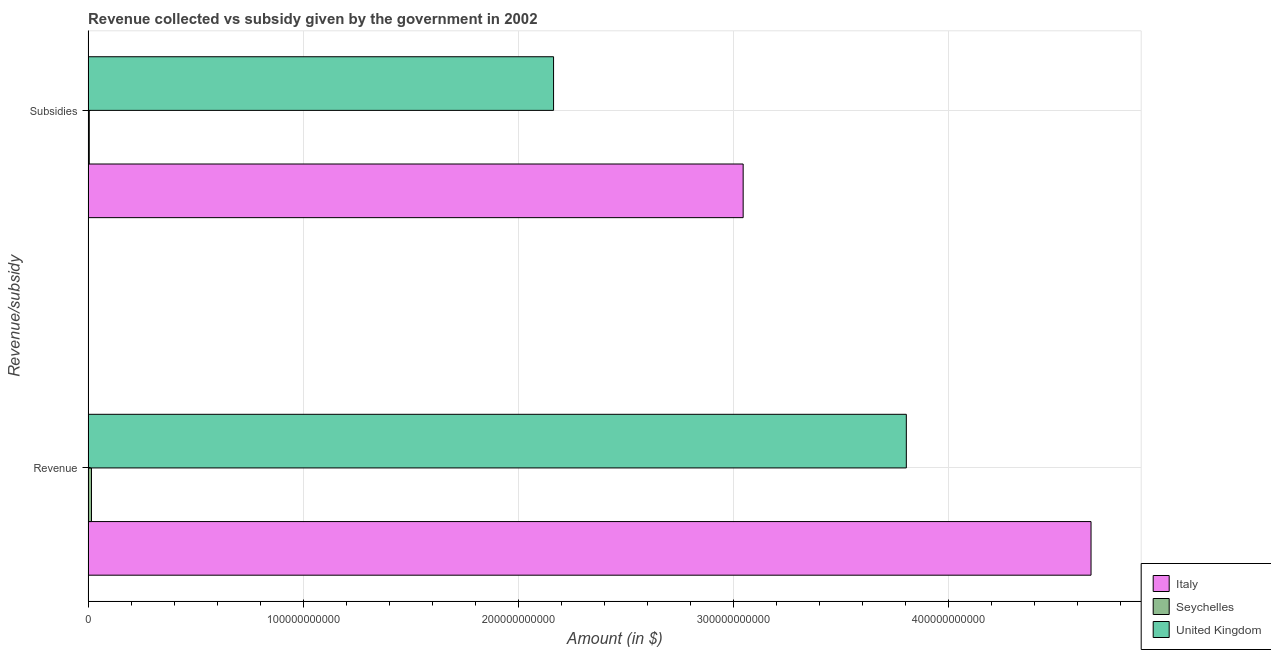How many different coloured bars are there?
Ensure brevity in your answer.  3. How many groups of bars are there?
Provide a short and direct response. 2. What is the label of the 1st group of bars from the top?
Your answer should be very brief. Subsidies. What is the amount of subsidies given in Italy?
Ensure brevity in your answer.  3.05e+11. Across all countries, what is the maximum amount of subsidies given?
Provide a succinct answer. 3.05e+11. Across all countries, what is the minimum amount of subsidies given?
Keep it short and to the point. 5.48e+08. In which country was the amount of revenue collected maximum?
Keep it short and to the point. Italy. In which country was the amount of subsidies given minimum?
Offer a terse response. Seychelles. What is the total amount of revenue collected in the graph?
Provide a short and direct response. 8.49e+11. What is the difference between the amount of revenue collected in Seychelles and that in Italy?
Provide a succinct answer. -4.65e+11. What is the difference between the amount of subsidies given in United Kingdom and the amount of revenue collected in Seychelles?
Give a very brief answer. 2.15e+11. What is the average amount of revenue collected per country?
Make the answer very short. 2.83e+11. What is the difference between the amount of revenue collected and amount of subsidies given in Seychelles?
Make the answer very short. 1.03e+09. What is the ratio of the amount of subsidies given in Seychelles to that in United Kingdom?
Offer a terse response. 0. What does the 2nd bar from the bottom in Subsidies represents?
Your answer should be very brief. Seychelles. How many bars are there?
Offer a terse response. 6. Are all the bars in the graph horizontal?
Provide a succinct answer. Yes. How many countries are there in the graph?
Make the answer very short. 3. What is the difference between two consecutive major ticks on the X-axis?
Your answer should be very brief. 1.00e+11. Are the values on the major ticks of X-axis written in scientific E-notation?
Provide a short and direct response. No. Does the graph contain any zero values?
Your answer should be very brief. No. Where does the legend appear in the graph?
Give a very brief answer. Bottom right. How are the legend labels stacked?
Provide a short and direct response. Vertical. What is the title of the graph?
Give a very brief answer. Revenue collected vs subsidy given by the government in 2002. Does "Moldova" appear as one of the legend labels in the graph?
Your response must be concise. No. What is the label or title of the X-axis?
Offer a terse response. Amount (in $). What is the label or title of the Y-axis?
Keep it short and to the point. Revenue/subsidy. What is the Amount (in $) of Italy in Revenue?
Your answer should be compact. 4.66e+11. What is the Amount (in $) of Seychelles in Revenue?
Your answer should be compact. 1.58e+09. What is the Amount (in $) in United Kingdom in Revenue?
Your answer should be compact. 3.81e+11. What is the Amount (in $) in Italy in Subsidies?
Make the answer very short. 3.05e+11. What is the Amount (in $) of Seychelles in Subsidies?
Give a very brief answer. 5.48e+08. What is the Amount (in $) of United Kingdom in Subsidies?
Offer a very short reply. 2.16e+11. Across all Revenue/subsidy, what is the maximum Amount (in $) of Italy?
Ensure brevity in your answer.  4.66e+11. Across all Revenue/subsidy, what is the maximum Amount (in $) in Seychelles?
Your answer should be compact. 1.58e+09. Across all Revenue/subsidy, what is the maximum Amount (in $) in United Kingdom?
Ensure brevity in your answer.  3.81e+11. Across all Revenue/subsidy, what is the minimum Amount (in $) in Italy?
Provide a short and direct response. 3.05e+11. Across all Revenue/subsidy, what is the minimum Amount (in $) of Seychelles?
Ensure brevity in your answer.  5.48e+08. Across all Revenue/subsidy, what is the minimum Amount (in $) in United Kingdom?
Keep it short and to the point. 2.16e+11. What is the total Amount (in $) of Italy in the graph?
Your answer should be compact. 7.71e+11. What is the total Amount (in $) in Seychelles in the graph?
Provide a succinct answer. 2.13e+09. What is the total Amount (in $) of United Kingdom in the graph?
Ensure brevity in your answer.  5.97e+11. What is the difference between the Amount (in $) in Italy in Revenue and that in Subsidies?
Keep it short and to the point. 1.62e+11. What is the difference between the Amount (in $) of Seychelles in Revenue and that in Subsidies?
Ensure brevity in your answer.  1.03e+09. What is the difference between the Amount (in $) in United Kingdom in Revenue and that in Subsidies?
Provide a short and direct response. 1.64e+11. What is the difference between the Amount (in $) of Italy in Revenue and the Amount (in $) of Seychelles in Subsidies?
Offer a terse response. 4.66e+11. What is the difference between the Amount (in $) in Italy in Revenue and the Amount (in $) in United Kingdom in Subsidies?
Provide a succinct answer. 2.50e+11. What is the difference between the Amount (in $) of Seychelles in Revenue and the Amount (in $) of United Kingdom in Subsidies?
Your answer should be compact. -2.15e+11. What is the average Amount (in $) in Italy per Revenue/subsidy?
Make the answer very short. 3.86e+11. What is the average Amount (in $) of Seychelles per Revenue/subsidy?
Provide a short and direct response. 1.06e+09. What is the average Amount (in $) in United Kingdom per Revenue/subsidy?
Your answer should be very brief. 2.99e+11. What is the difference between the Amount (in $) of Italy and Amount (in $) of Seychelles in Revenue?
Make the answer very short. 4.65e+11. What is the difference between the Amount (in $) of Italy and Amount (in $) of United Kingdom in Revenue?
Give a very brief answer. 8.59e+1. What is the difference between the Amount (in $) in Seychelles and Amount (in $) in United Kingdom in Revenue?
Give a very brief answer. -3.79e+11. What is the difference between the Amount (in $) in Italy and Amount (in $) in Seychelles in Subsidies?
Your answer should be very brief. 3.04e+11. What is the difference between the Amount (in $) of Italy and Amount (in $) of United Kingdom in Subsidies?
Your answer should be very brief. 8.82e+1. What is the difference between the Amount (in $) of Seychelles and Amount (in $) of United Kingdom in Subsidies?
Make the answer very short. -2.16e+11. What is the ratio of the Amount (in $) of Italy in Revenue to that in Subsidies?
Make the answer very short. 1.53. What is the ratio of the Amount (in $) in Seychelles in Revenue to that in Subsidies?
Your answer should be compact. 2.89. What is the ratio of the Amount (in $) in United Kingdom in Revenue to that in Subsidies?
Provide a succinct answer. 1.76. What is the difference between the highest and the second highest Amount (in $) of Italy?
Your response must be concise. 1.62e+11. What is the difference between the highest and the second highest Amount (in $) of Seychelles?
Offer a very short reply. 1.03e+09. What is the difference between the highest and the second highest Amount (in $) in United Kingdom?
Keep it short and to the point. 1.64e+11. What is the difference between the highest and the lowest Amount (in $) of Italy?
Make the answer very short. 1.62e+11. What is the difference between the highest and the lowest Amount (in $) in Seychelles?
Ensure brevity in your answer.  1.03e+09. What is the difference between the highest and the lowest Amount (in $) in United Kingdom?
Keep it short and to the point. 1.64e+11. 